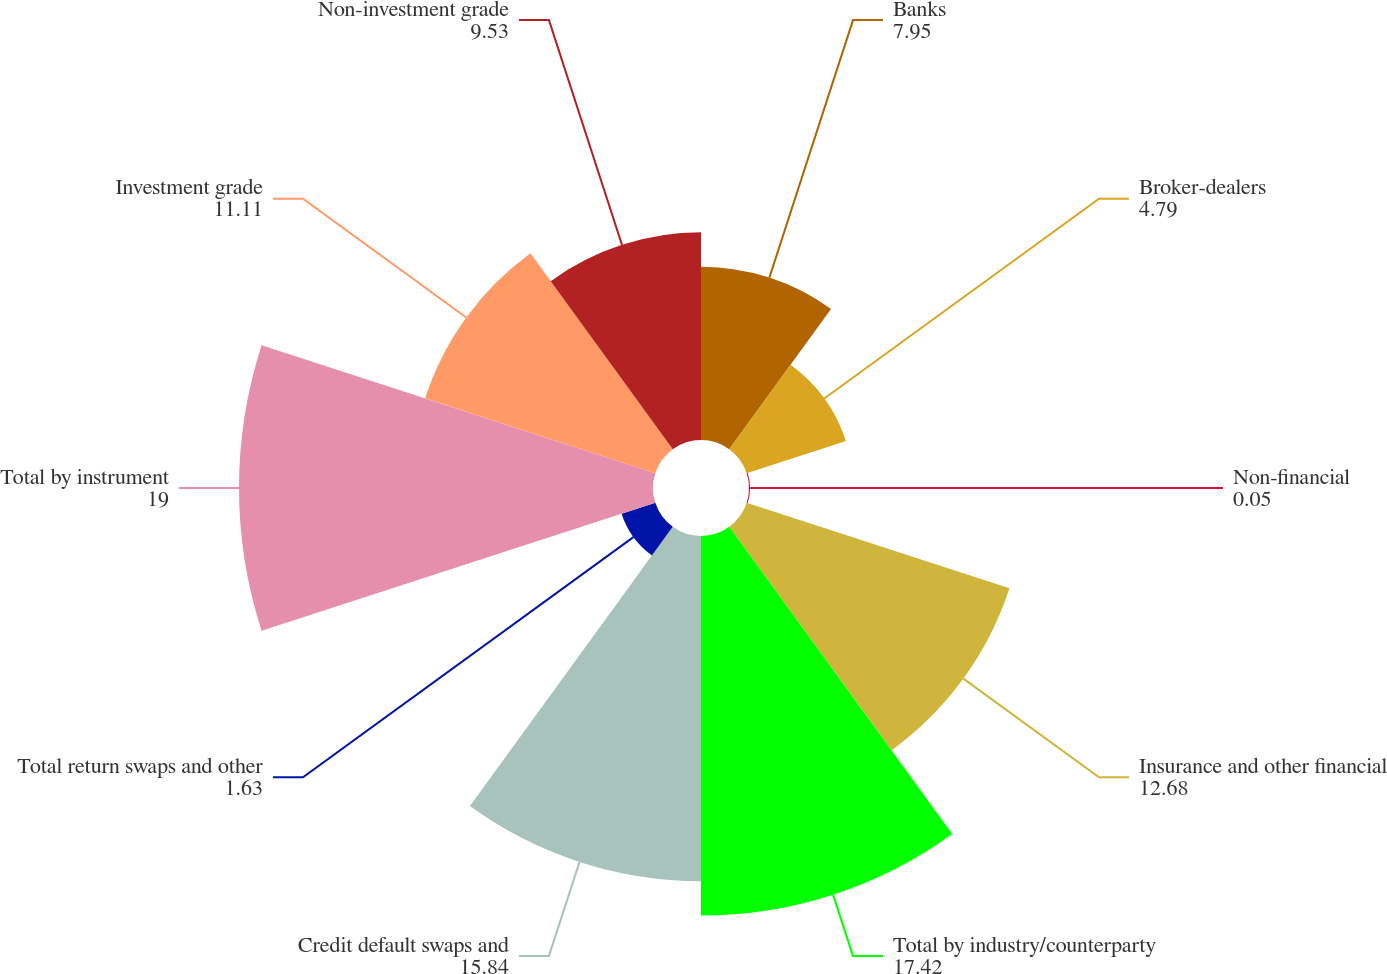Convert chart to OTSL. <chart><loc_0><loc_0><loc_500><loc_500><pie_chart><fcel>Banks<fcel>Broker-dealers<fcel>Non-financial<fcel>Insurance and other financial<fcel>Total by industry/counterparty<fcel>Credit default swaps and<fcel>Total return swaps and other<fcel>Total by instrument<fcel>Investment grade<fcel>Non-investment grade<nl><fcel>7.95%<fcel>4.79%<fcel>0.05%<fcel>12.68%<fcel>17.42%<fcel>15.84%<fcel>1.63%<fcel>19.0%<fcel>11.11%<fcel>9.53%<nl></chart> 